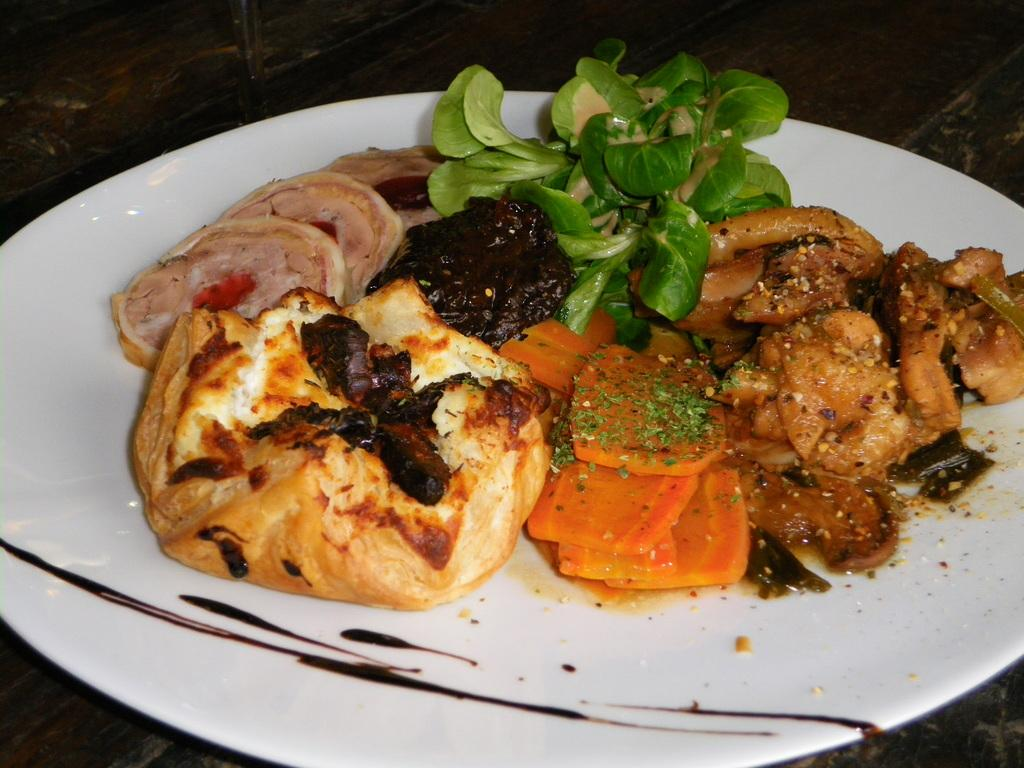What is on the plate that is visible in the image? There are food items on a plate in the image. What color is the plate? The plate is white in color. What type of surface is the plate resting on? The plate is on a wooden surface. Can you see any beans floating in space in the image? There are no beans or space present in the image; it features a plate with food items on a wooden surface. 